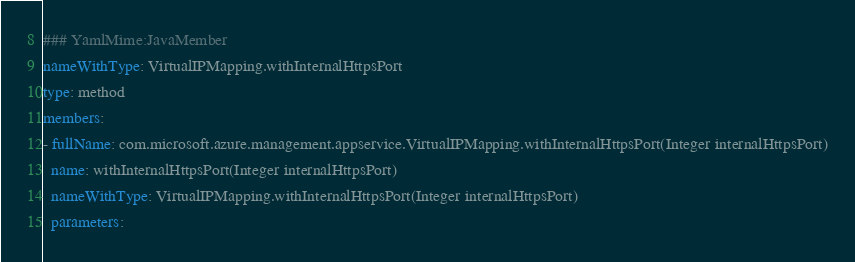Convert code to text. <code><loc_0><loc_0><loc_500><loc_500><_YAML_>### YamlMime:JavaMember
nameWithType: VirtualIPMapping.withInternalHttpsPort
type: method
members:
- fullName: com.microsoft.azure.management.appservice.VirtualIPMapping.withInternalHttpsPort(Integer internalHttpsPort)
  name: withInternalHttpsPort(Integer internalHttpsPort)
  nameWithType: VirtualIPMapping.withInternalHttpsPort(Integer internalHttpsPort)
  parameters:</code> 